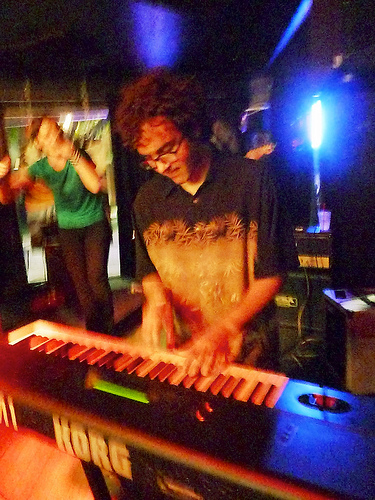<image>
Can you confirm if the woman is behind the man? Yes. From this viewpoint, the woman is positioned behind the man, with the man partially or fully occluding the woman. 